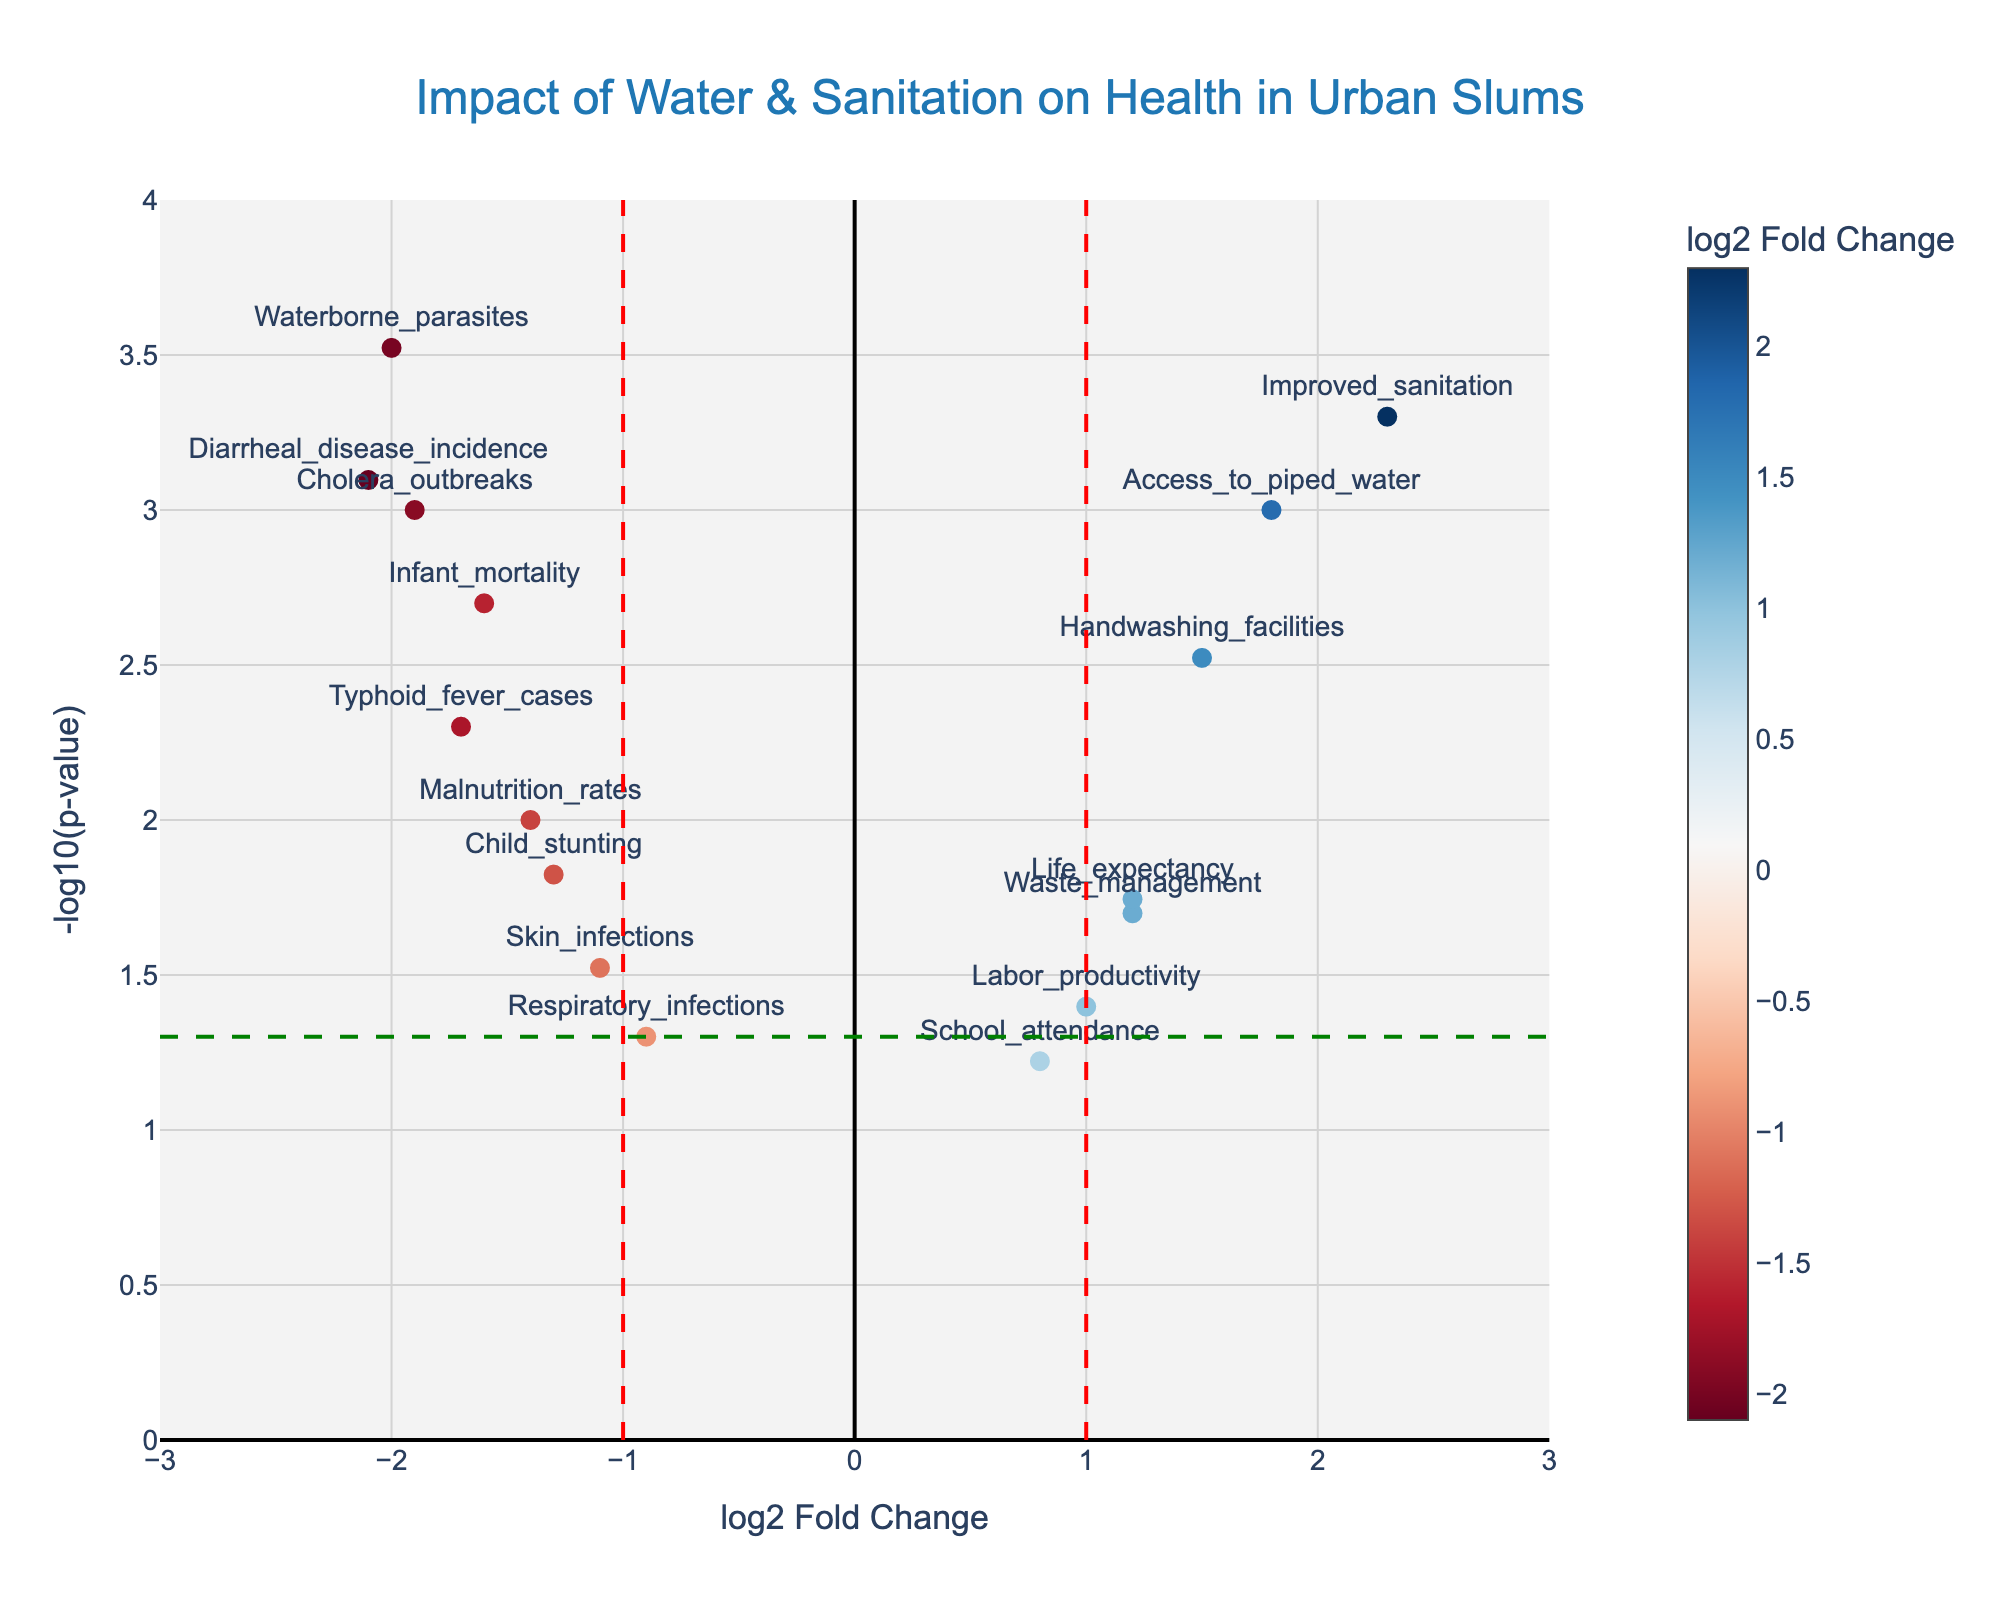What is the title of the plot? The title of the plot is usually placed at the top center and clearly indicates the topic of the visualization. Here, it is "Impact of Water & Sanitation on Health in Urban Slums".
Answer: Impact of Water & Sanitation on Health in Urban Slums Which variable has the highest log2 Fold Change? To determine this, look for the data point with the highest x-coordinate (log2 Fold Change) value. "Improved_sanitation" has the highest log2 Fold Change at 2.3.
Answer: Improved_sanitation What is the color range of the markers? The color range of the markers indicates the log2 Fold Change values, which are shown on the color scale on the right side of the plot. The colors range from negative to positive values using a "RdBu" colorscale.
Answer: RdBu colorscale Which gene is associated with the lowest p-value? The lowest p-value corresponds to the highest point on the y-axis (-log10(p-value)). "Waterborne_parasites" has the highest -log10(p-value) and thus the lowest p-value.
Answer: Waterborne_parasites How many data points have a p-value less than 0.05? Data points with a p-value less than 0.05 will be above the horizontal dashed green line (-log10(0.05)). Count the number of markers above this line excluding those touching or below it. There are 15 data points above the line.
Answer: 15 Which variables are positively correlated with health outcomes? Variables with positive log2 Fold Change values on the x-axis indicate a positive correlation. Examples include "Access_to_piped_water," "Improved_sanitation," "Handwashing_facilities," "Life_expectancy," and "Labor_productivity".
Answer: Access_to_piped_water, Improved_sanitation, Handwashing_facilities, Life_expectancy, Labor_productivity What is the log2 Fold Change and p-value for "Diarrheal_disease_incidence"? Locate the point labeled "Diarrheal_disease_incidence" on the plot and read its x-coordinate for log2 Fold Change and y-coordinate (converted from -log10(p-value)). The values are approximately -2.1 for log2 Fold Change and 0.0008 for the p-value.
Answer: log2 Fold Change: -2.1, p-value: 0.0008 Are there more health outcome variables with positive or negative correlations? Count the number of health outcome variables (e.g., disease incidence, mortality) on either side of the x-axis. There are 6 health outcome variables with negative correlations and 0 with positive correlations.
Answer: More with negative correlations What does the vertical red dashed line at x = 1 signify? The vertical red dashed line at x = 1 marks a threshold for a significant positive log2 Fold Change. Points to the right have a log2 Fold Change greater than 1, often indicating a strong positive correlation.
Answer: Significant positive log2 Fold Change threshold 